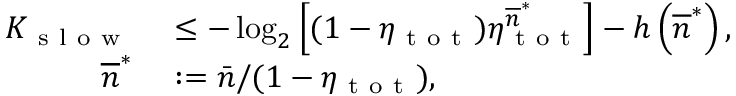Convert formula to latex. <formula><loc_0><loc_0><loc_500><loc_500>\begin{array} { r l } { K _ { s l o w } } & \leq - \log _ { 2 } \left [ ( 1 - \eta _ { t o t } ) \eta _ { t o t } ^ { \overline { n } ^ { \ast } } \right ] - h \left ( \overline { n } ^ { \ast } \right ) , } \\ { \overline { n } ^ { \ast } } & \colon = \bar { n } / ( 1 - \eta _ { t o t } ) , } \end{array}</formula> 